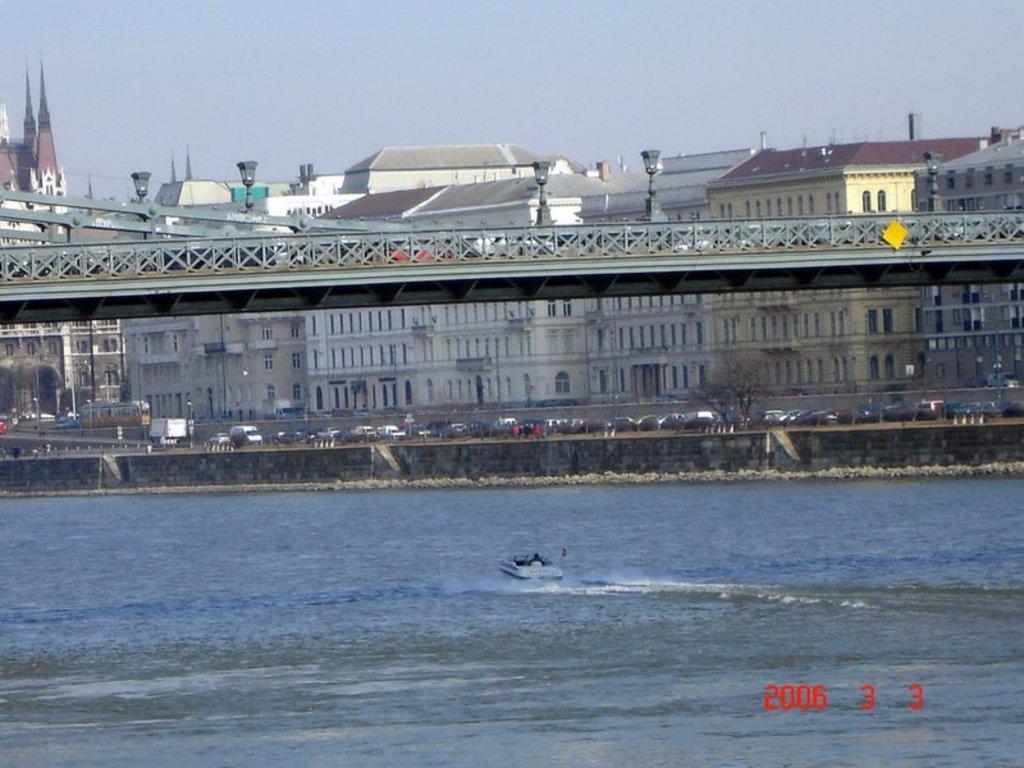Please provide a concise description of this image. In the picture I can see a boat is floating in the water, I can see bridge, vehicles moving on the road, I can see the buildings and the sky in the background. Here I can see the watermark at the bottom right side of the image. 